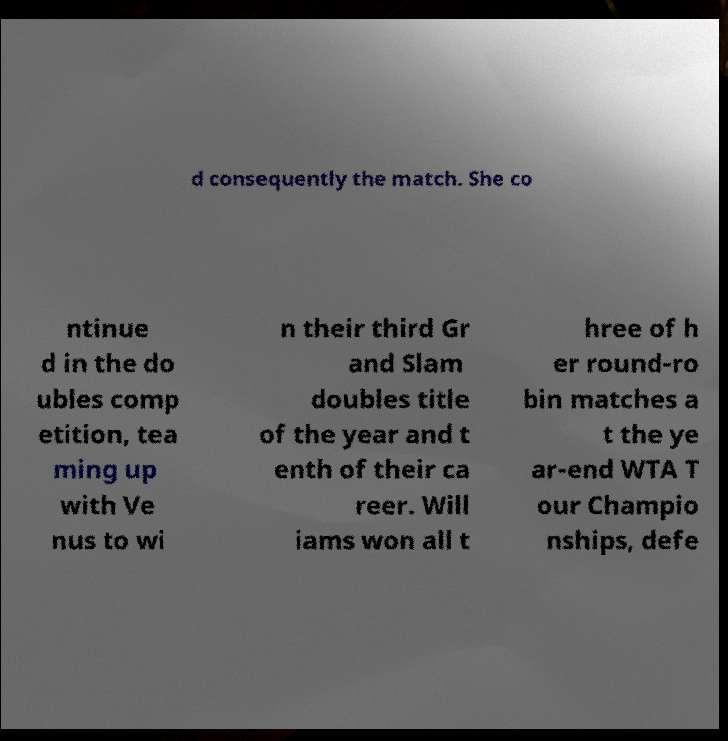Could you extract and type out the text from this image? d consequently the match. She co ntinue d in the do ubles comp etition, tea ming up with Ve nus to wi n their third Gr and Slam doubles title of the year and t enth of their ca reer. Will iams won all t hree of h er round-ro bin matches a t the ye ar-end WTA T our Champio nships, defe 